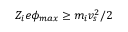Convert formula to latex. <formula><loc_0><loc_0><loc_500><loc_500>Z _ { i } e \phi _ { \max } \geq m _ { i } v _ { s } ^ { 2 } / 2</formula> 